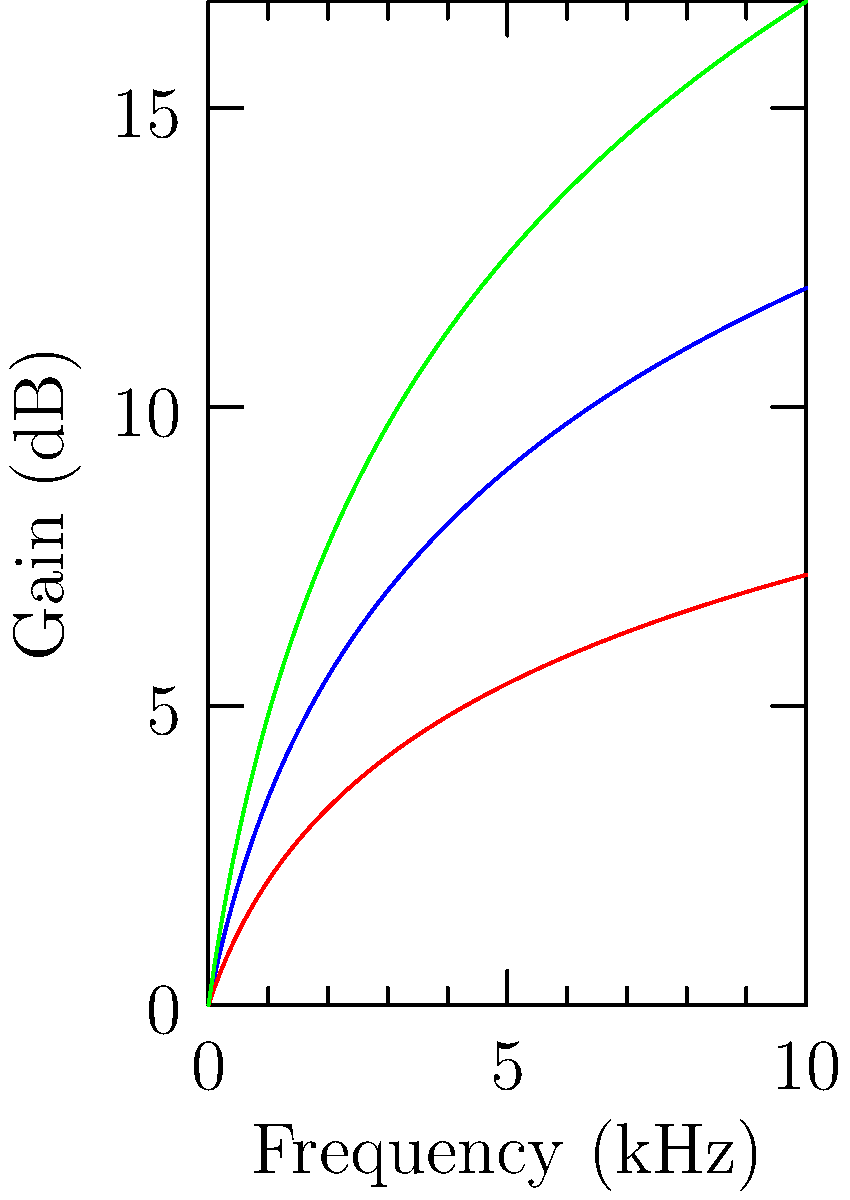Based on the frequency response curves shown for three different hearing aid models (A, B, and C), which model would be most suitable for a patient with severe high-frequency hearing loss? To determine the most suitable hearing aid model for a patient with severe high-frequency hearing loss, we need to analyze the frequency response curves:

1. High-frequency response: We're looking for the model that provides the highest gain at higher frequencies (right side of the graph).

2. Curve analysis:
   - Model A (blue): Moderate gain across frequencies, balanced response.
   - Model B (red): Lowest overall gain, less suitable for severe loss.
   - Model C (green): Highest gain, especially at higher frequencies.

3. Severe high-frequency loss: Requires significant amplification at higher frequencies to compensate for the hearing deficit.

4. Comparing the curves:
   - Model C provides the steepest curve and highest gain at high frequencies.
   - Model A offers moderate amplification but less than Model C.
   - Model B provides the least amplification and is unsuitable for severe loss.

5. Conclusion: Model C (green) offers the most significant amplification at higher frequencies, making it the most suitable choice for a patient with severe high-frequency hearing loss.
Answer: Model C 